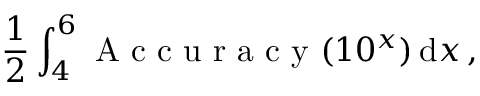<formula> <loc_0><loc_0><loc_500><loc_500>\frac { 1 } { 2 } \int _ { 4 } ^ { 6 } A c c u r a c y ( 1 0 ^ { x } ) \, d x \, ,</formula> 